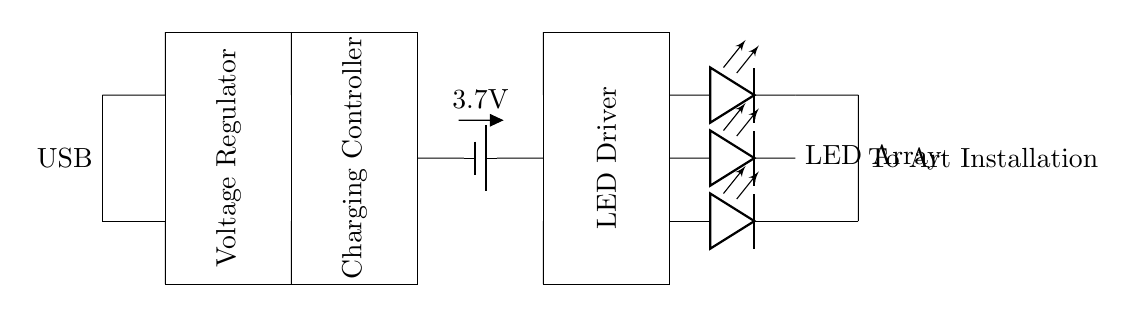What is the input type for this charging circuit? The input type is USB, which is indicated as the source in the circuit diagram. There are connections drawn from a USB port at the left side, confirming that it is the power source.
Answer: USB What is the voltage output from the battery? The battery is labeled with a voltage of 3.7V, which is directly shown as part of the circuit diagram. This indicates the stored voltage that the battery provides.
Answer: 3.7V What component regulates the charging process? The charging controller is the component responsible for managing the charging process. It is represented as a rectangle in the diagram with a label explicitly stating "Charging Controller."
Answer: Charging Controller How many LEDs are present in the LED array? The LED array consists of three LEDs in parallel, as indicated in the circuit diagram where there are three distinct LED representations. Each LED has its own connection point.
Answer: 3 What is the role of the voltage regulator in this circuit? The voltage regulator ensures that the output voltage remains stable, even if the input fluctuates. This is crucial in charging circuits to prevent damage to the battery and connected devices. The component labeled "Voltage Regulator" clearly indicates this function.
Answer: Stabilizing voltage How does the LED driver interact with the LED array? The LED driver supplies the necessary current to the LED array to ensure proper illumination. The driver is connected to the LED array, providing power that allows the LEDs to light up, as shown by the directional connections in the diagram.
Answer: Supplies current What type of connection is used to transfer power to the art installation? The connections to the art installation are short connections that run from the LED array. These are shown exiting on the right side of the diagram, indicating the output path of power transfer.
Answer: Short connections 